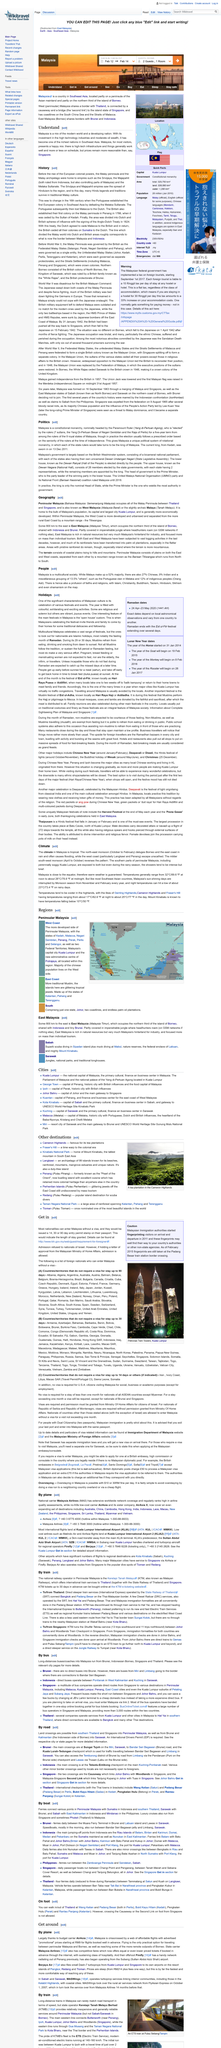Draw attention to some important aspects in this diagram. Peninsular Malaysia, also known as West Malaysia and Malaya, is a region that is renowned for its rich cultural heritage and stunning natural beauty. The name of the train state operator in Malaysia is Keretapi Tanah Melayu Berhad. Yes, it is possible to enter Thailand by foot, as walking out of Thailand is an option in certain cities, including Wang Kelian in Perlis and Pengkalan Hulu in Perak. The Main Western Line connects Butterworth and Woodlands, providing a critical transportation link between these two locations. Luxury cruises and ferries can be seen in the southwest Asian region around Thailand, Malaysia, Indonesia, Singapore, and Brunei. 